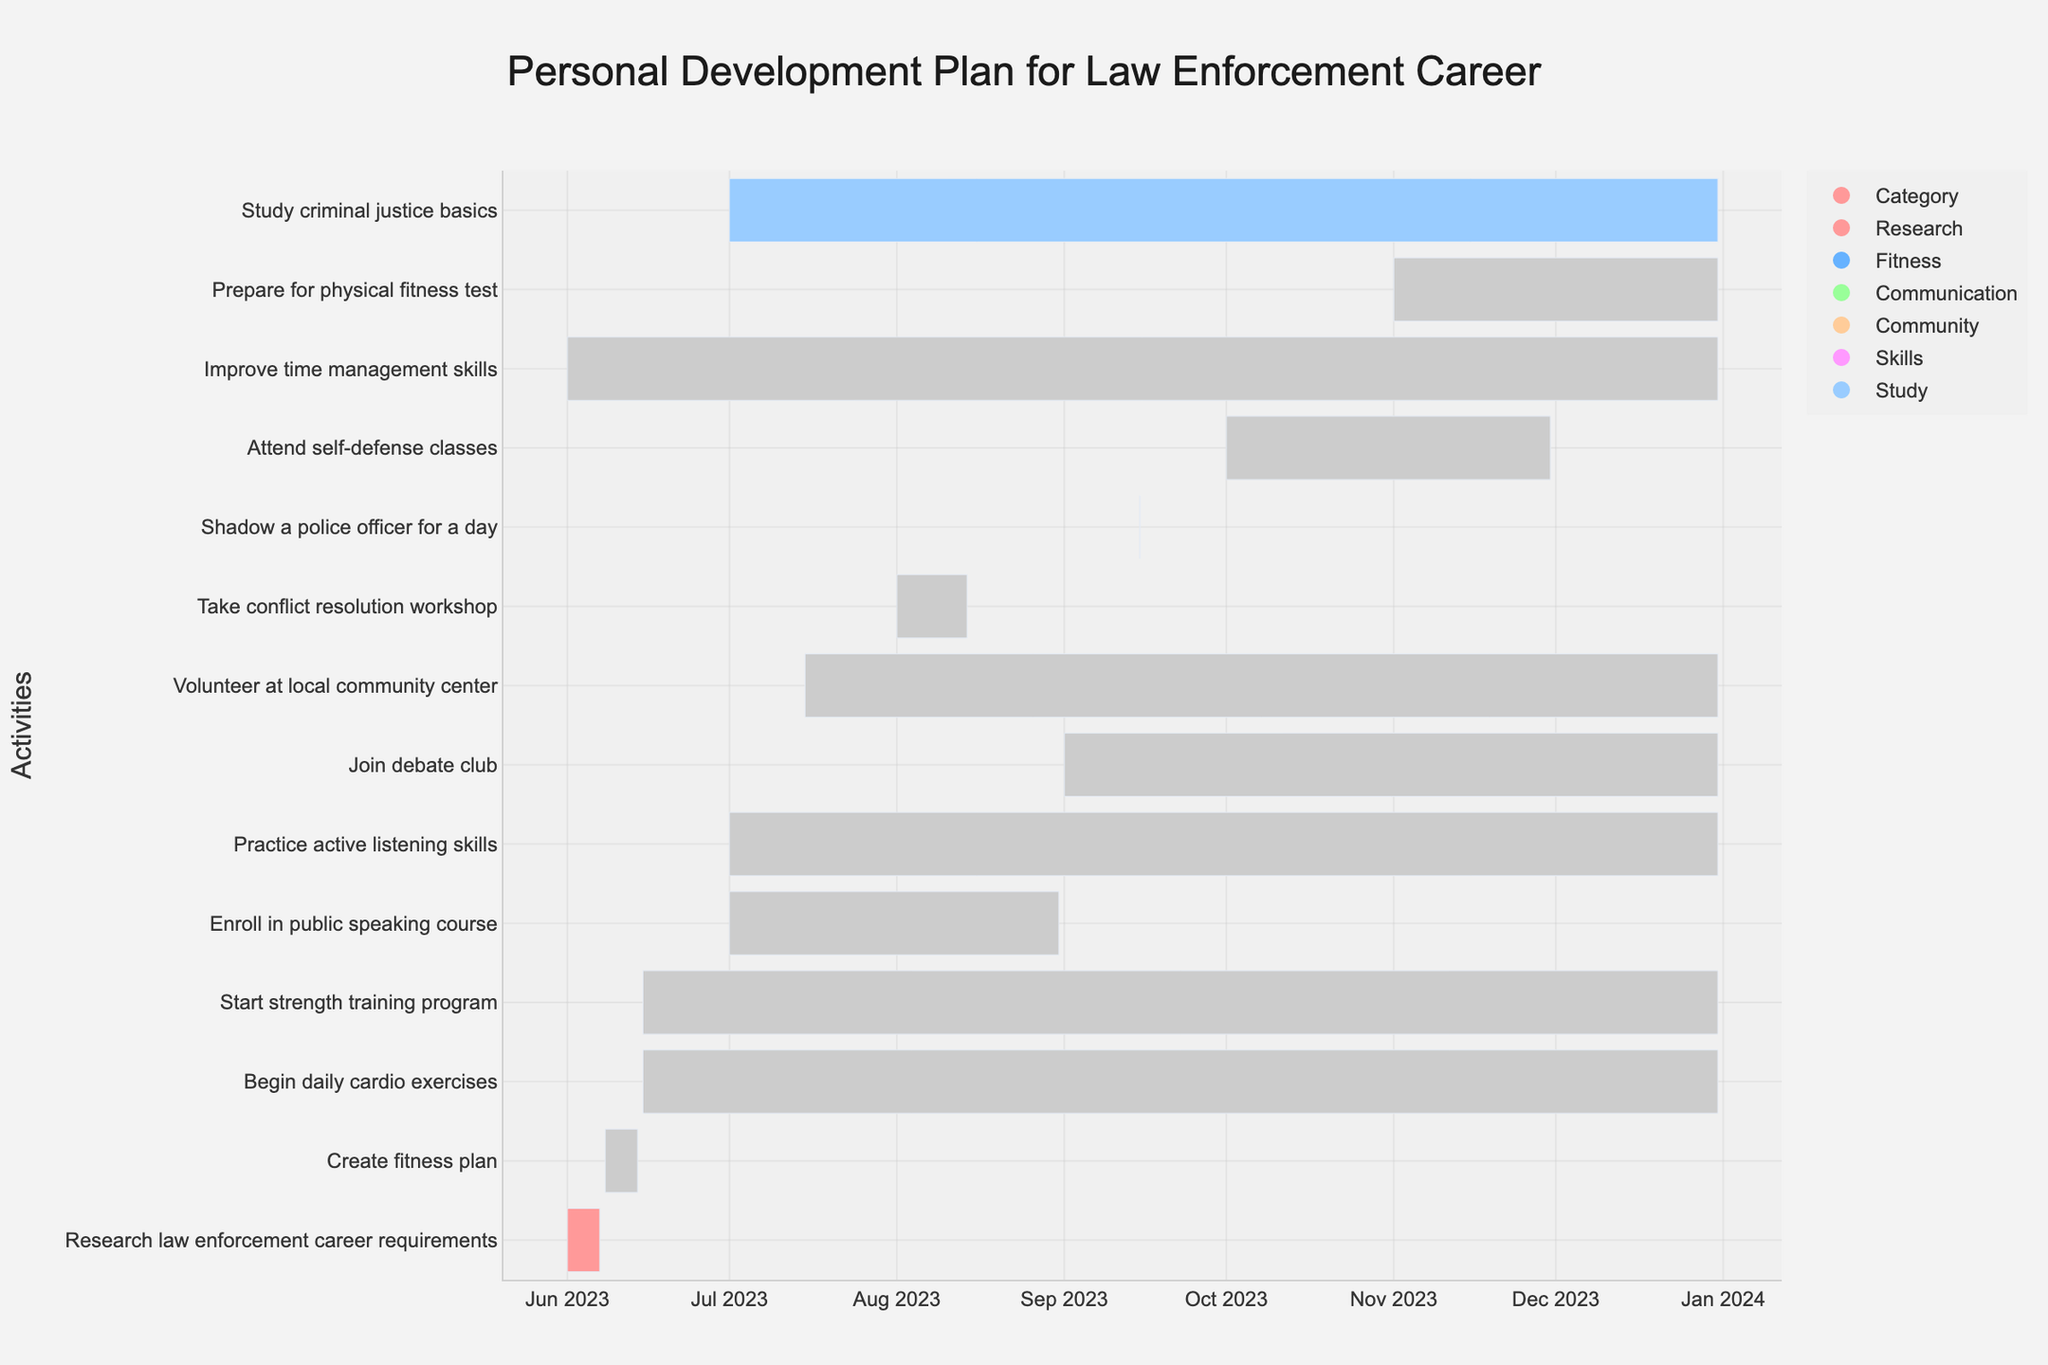What is the title of the Gantt chart? The title is displayed at the top of the chart. You can see it in large, bold font.
Answer: Personal Development Plan for Law Enforcement Career How many tasks are displayed in the Gantt chart? You need to count the number of tasks listed on the y-axis. Each task represents one line in the chart.
Answer: 14 Which task has the longest duration? Compare the durations as shown by the length of the bars. The longest bar will represent the longest duration.
Answer: Improve time management skills What color represents the fitness-related tasks? Check the color of the bars associated with tasks that are fitness-related, such as "Create fitness plan" and "Begin daily cardio exercises."
Answer: Light blue When does the "Enroll in public speaking course" task begin and end? Locate the task on the y-axis, then check the corresponding start and end dates shown on the x-axis.
Answer: July 1, 2023 to August 31, 2023 What is the duration of the "Take conflict resolution workshop" task? Locate the task on the y-axis and check the width of the bar, specifically noting the hover information that displays the duration.
Answer: 14 days Which tasks are categorized under "Community" based on their color? Identify the color associated with the "Community" category in the legend, and then locate the tasks with the same color.
Answer: Volunteer at local community center, Shadow a police officer for a day How many tasks start on June 15, 2023? Check the start dates on the x-axis and count the number of tasks that have their starting point on June 15, 2023.
Answer: 2 Compare the durations of "Practice active listening skills" and "Join debate club". Which one lasts longer? Look at the two tasks on the y-axis and compare the lengths of their bars to determine which one spans a longer period.
Answer: Practice active listening skills Which task has the shortest duration, and how long is it? Identify the task with the shortest bar and check the hover information or bar to find its duration.
Answer: Shadow a police officer for a day, 1 day 